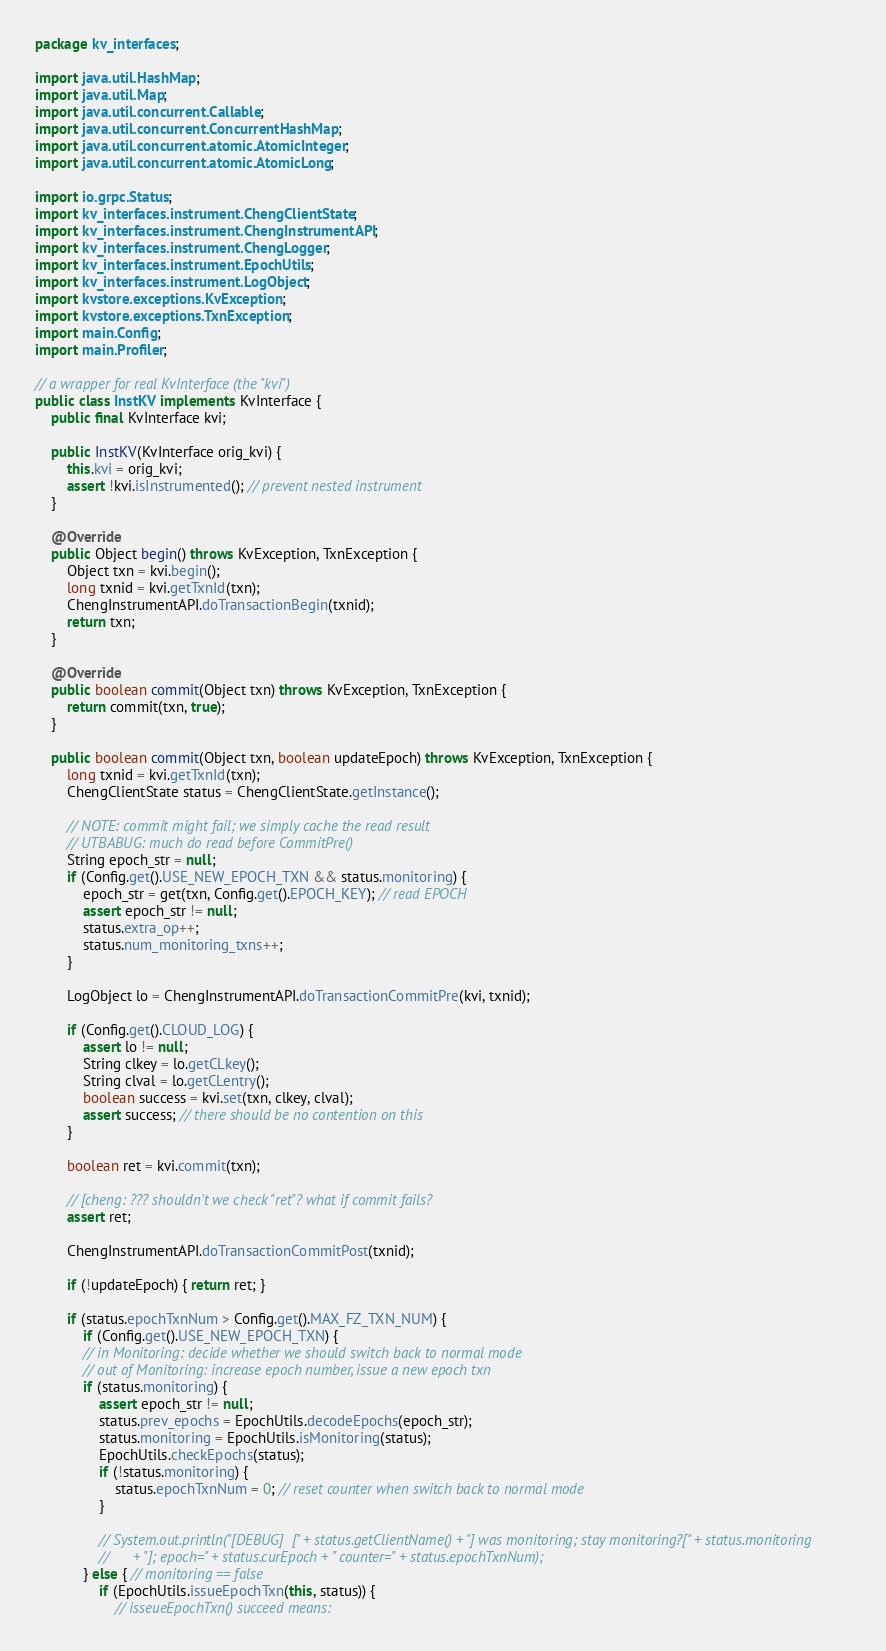<code> <loc_0><loc_0><loc_500><loc_500><_Java_>package kv_interfaces;

import java.util.HashMap;
import java.util.Map;
import java.util.concurrent.Callable;
import java.util.concurrent.ConcurrentHashMap;
import java.util.concurrent.atomic.AtomicInteger;
import java.util.concurrent.atomic.AtomicLong;

import io.grpc.Status;
import kv_interfaces.instrument.ChengClientState;
import kv_interfaces.instrument.ChengInstrumentAPI;
import kv_interfaces.instrument.ChengLogger;
import kv_interfaces.instrument.EpochUtils;
import kv_interfaces.instrument.LogObject;
import kvstore.exceptions.KvException;
import kvstore.exceptions.TxnException;
import main.Config;
import main.Profiler;

// a wrapper for real KvInterface (the "kvi")
public class InstKV implements KvInterface {
	public final KvInterface kvi;

	public InstKV(KvInterface orig_kvi) {
		this.kvi = orig_kvi;
		assert !kvi.isInstrumented(); // prevent nested instrument
	}

	@Override
	public Object begin() throws KvException, TxnException {
		Object txn = kvi.begin();
		long txnid = kvi.getTxnId(txn);
		ChengInstrumentAPI.doTransactionBegin(txnid);
		return txn;
	}

	@Override
	public boolean commit(Object txn) throws KvException, TxnException {
		return commit(txn, true);
	}
	
	public boolean commit(Object txn, boolean updateEpoch) throws KvException, TxnException {
		long txnid = kvi.getTxnId(txn);
		ChengClientState status = ChengClientState.getInstance();
		
		// NOTE: commit might fail; we simply cache the read result
		// UTBABUG: much do read before CommitPre()
		String epoch_str = null;
		if (Config.get().USE_NEW_EPOCH_TXN && status.monitoring) {
			epoch_str = get(txn, Config.get().EPOCH_KEY); // read EPOCH
			assert epoch_str != null;
			status.extra_op++;
			status.num_monitoring_txns++;
		}
		
		LogObject lo = ChengInstrumentAPI.doTransactionCommitPre(kvi, txnid);

		if (Config.get().CLOUD_LOG) {
			assert lo != null;
			String clkey = lo.getCLkey();
			String clval = lo.getCLentry();
			boolean success = kvi.set(txn, clkey, clval);
			assert success; // there should be no contention on this
		}

		boolean ret = kvi.commit(txn);

		// [cheng: ??? shouldn't we check "ret"? what if commit fails?
		assert ret;
		
		ChengInstrumentAPI.doTransactionCommitPost(txnid);
		
		if (!updateEpoch) { return ret; }
		
		if (status.epochTxnNum > Config.get().MAX_FZ_TXN_NUM) {
			if (Config.get().USE_NEW_EPOCH_TXN) {
			// in Monitoring: decide whether we should switch back to normal mode
			// out of Monitoring: increase epoch number, issue a new epoch txn
			if (status.monitoring) {
				assert epoch_str != null;
				status.prev_epochs = EpochUtils.decodeEpochs(epoch_str);
				status.monitoring = EpochUtils.isMonitoring(status);
				EpochUtils.checkEpochs(status);
				if (!status.monitoring) {
					status.epochTxnNum = 0; // reset counter when switch back to normal mode
				}

				// System.out.println("[DEBUG]  [" + status.getClientName() + "] was monitoring; stay monitoring?[" + status.monitoring
				//		+ "]; epoch=" + status.curEpoch + " counter=" + status.epochTxnNum);
			} else { // monitoring == false
				if (EpochUtils.issueEpochTxn(this, status)) {
					// isseueEpochTxn() succeed means:</code> 